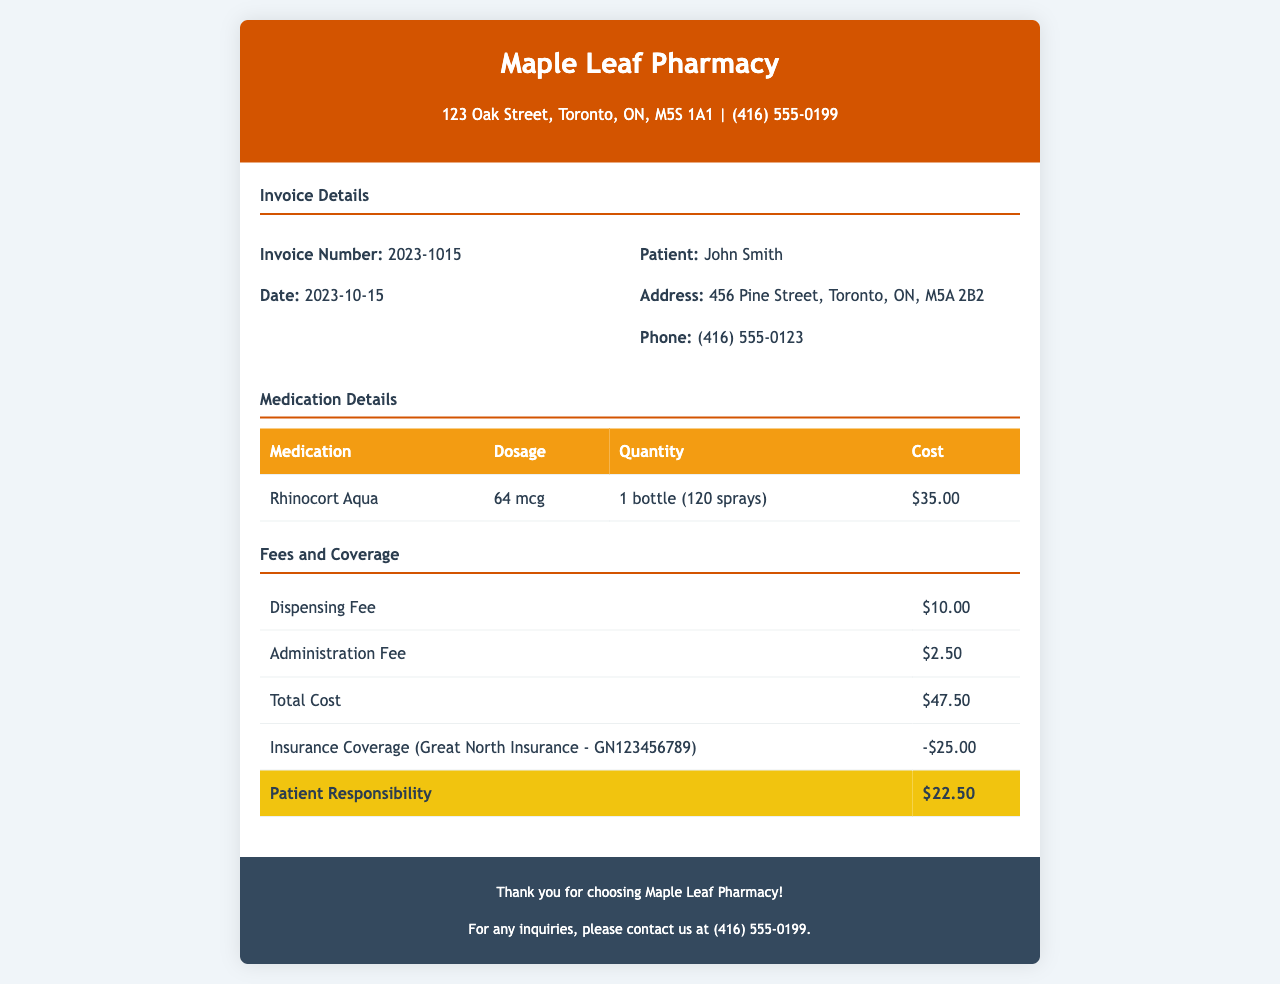What is the invoice number? The invoice number is listed in the invoice details section under "Invoice Number".
Answer: 2023-1015 What is the date of the invoice? The date appears in the invoice details section next to "Date".
Answer: 2023-10-15 What is the cost of Rhinocort Aqua? The cost of Rhinocort Aqua can be found in the medication details table under "Cost".
Answer: $35.00 What is the dispensing fee? The dispensing fee is indicated in the fees and coverage section.
Answer: $10.00 What is the total cost before insurance coverage? The total cost is specified in the fees and coverage section under "Total Cost".
Answer: $47.50 How much does insurance cover? The insurance coverage amount is shown in the fees and coverage table under "Insurance Coverage".
Answer: -$25.00 What is the patient responsibility after insurance? The patient responsibility is detailed in the fees and coverage section under "Patient Responsibility".
Answer: $22.50 What is the administration fee? The administration fee is listed in the fees and coverage details.
Answer: $2.50 Who is the insurance provider? The insurance provider is mentioned alongside the coverage amount in the fees and coverage section.
Answer: Great North Insurance 